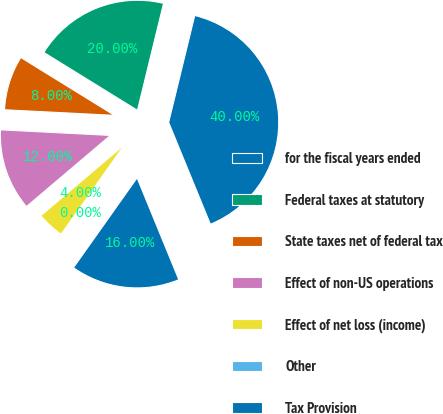<chart> <loc_0><loc_0><loc_500><loc_500><pie_chart><fcel>for the fiscal years ended<fcel>Federal taxes at statutory<fcel>State taxes net of federal tax<fcel>Effect of non-US operations<fcel>Effect of net loss (income)<fcel>Other<fcel>Tax Provision<nl><fcel>40.0%<fcel>20.0%<fcel>8.0%<fcel>12.0%<fcel>4.0%<fcel>0.0%<fcel>16.0%<nl></chart> 